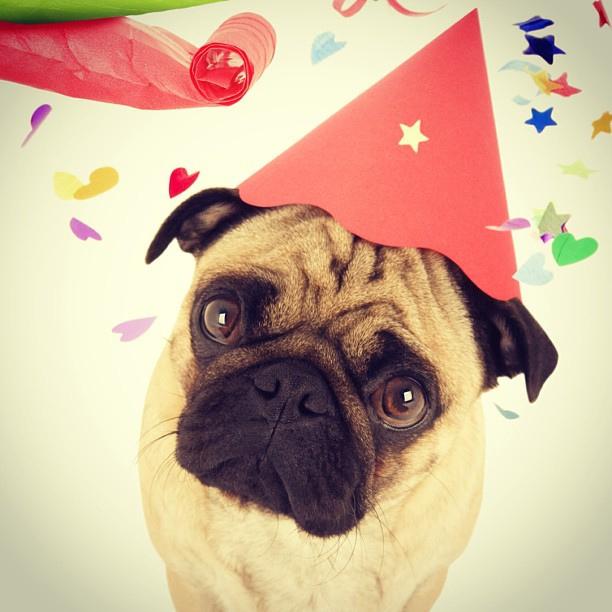What kind of dog is in the picture?
Be succinct. Pug. Why is the dog wearing this hat?
Quick response, please. Birthday. What shapes are the confetti?
Concise answer only. Stars and hearts. 